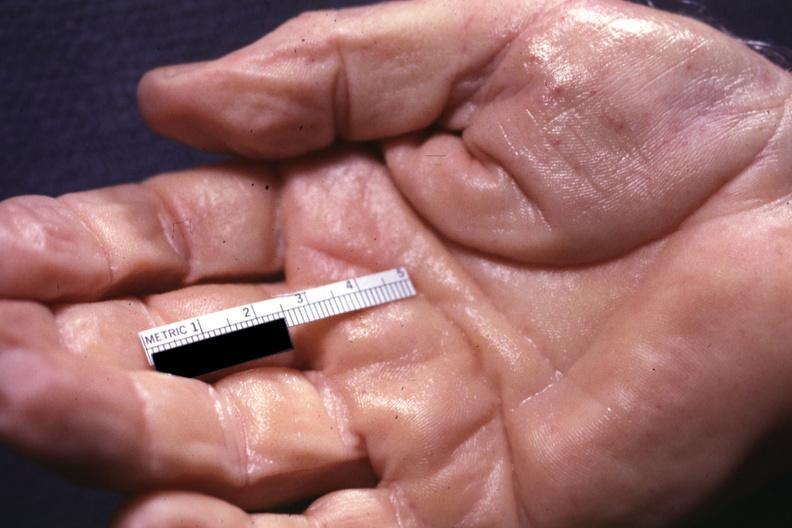s hemochromatosis present?
Answer the question using a single word or phrase. Yes 